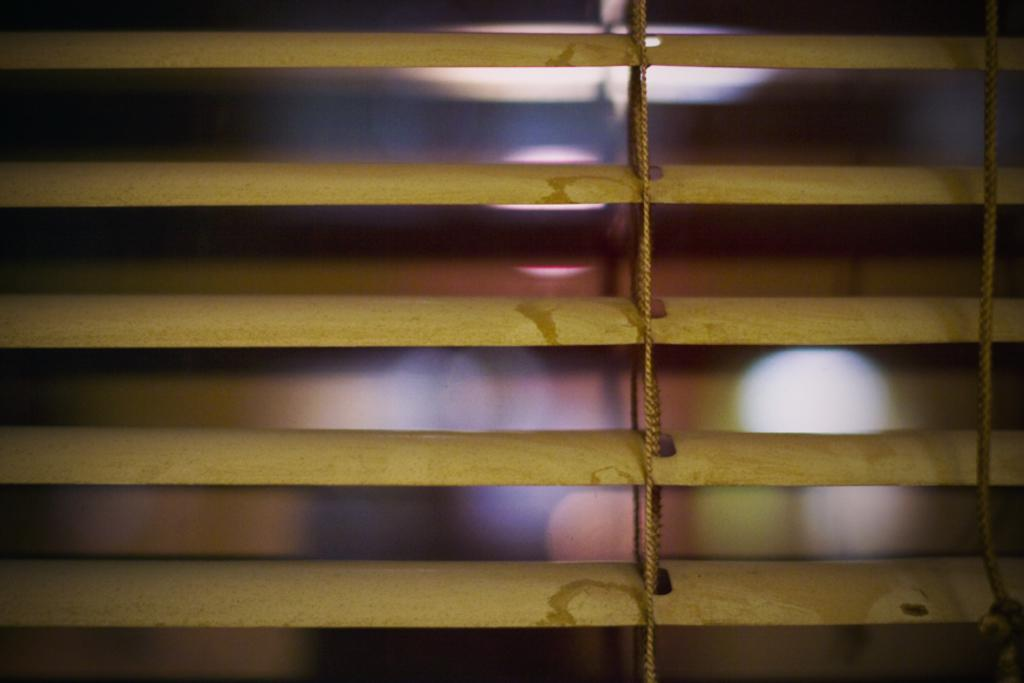What can be seen in the front of the image? There are things in the front of the image, including ropes. Can you describe any objects or features in the background of the image? There are lights in the background of the image. How would you describe the overall clarity of the image? The image is blurry. What type of holiday is being celebrated in the image? There is no indication of a holiday being celebrated in the image. What material is used to cover the ropes in the image? The provided facts do not mention any covering on the ropes. 